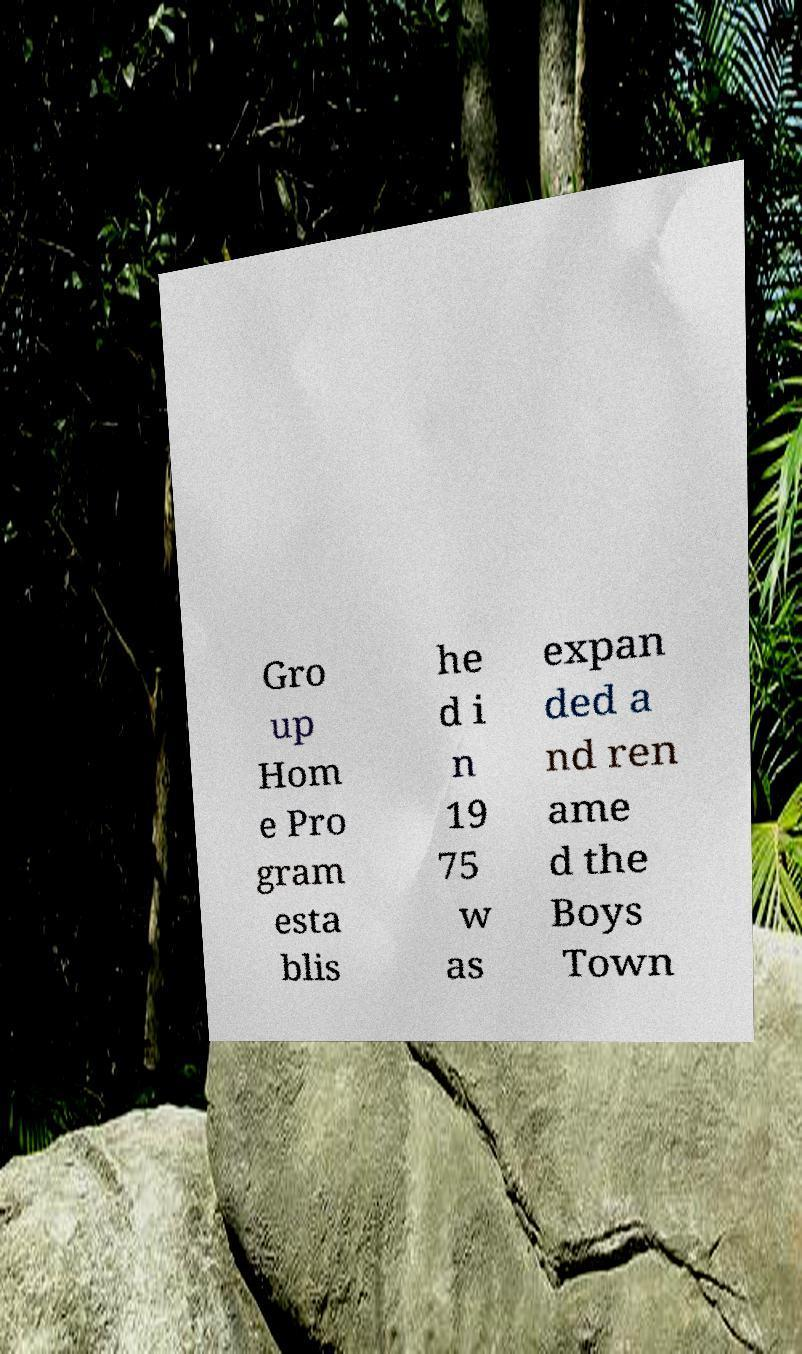Could you extract and type out the text from this image? Gro up Hom e Pro gram esta blis he d i n 19 75 w as expan ded a nd ren ame d the Boys Town 